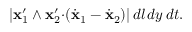<formula> <loc_0><loc_0><loc_500><loc_500>| { x } _ { 1 } ^ { \prime } \wedge { x } _ { 2 } ^ { \prime } { \cdot } ( \dot { x } _ { 1 } - \dot { x } _ { 2 } ) | \, d l \, d y \, d t .</formula> 